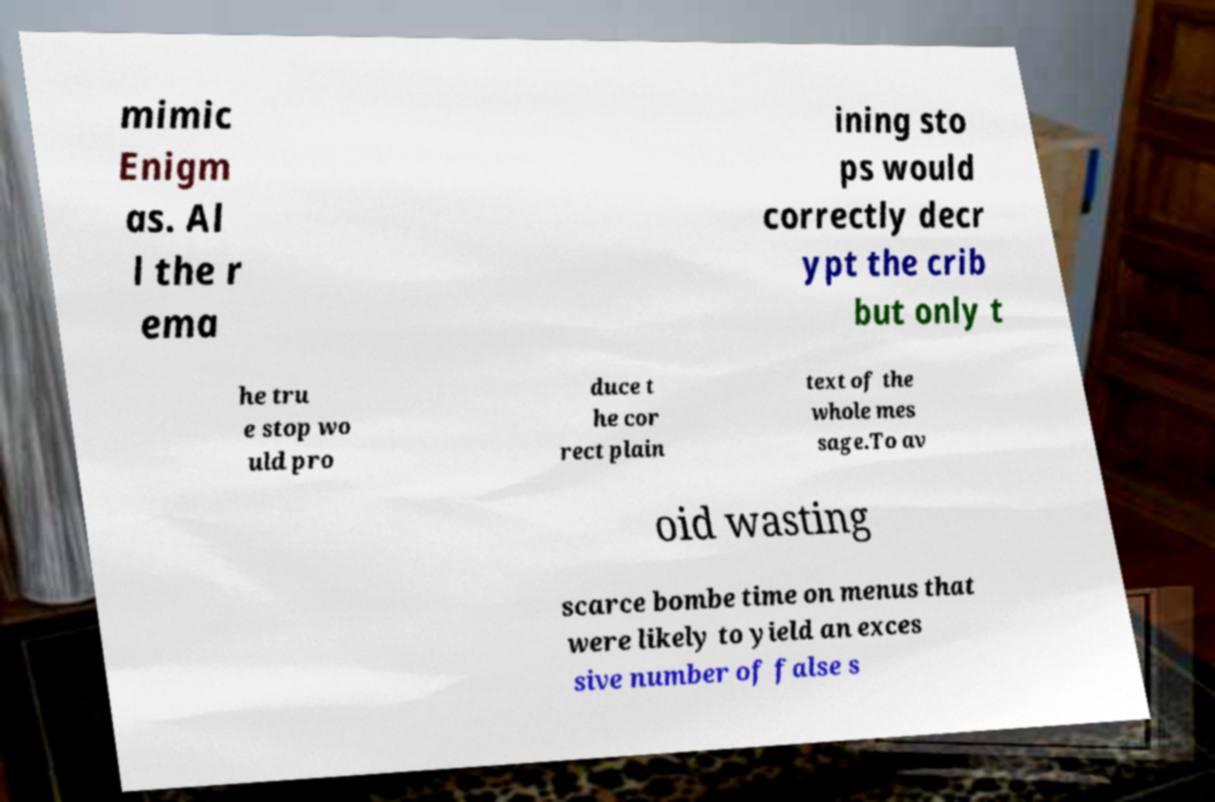I need the written content from this picture converted into text. Can you do that? mimic Enigm as. Al l the r ema ining sto ps would correctly decr ypt the crib but only t he tru e stop wo uld pro duce t he cor rect plain text of the whole mes sage.To av oid wasting scarce bombe time on menus that were likely to yield an exces sive number of false s 